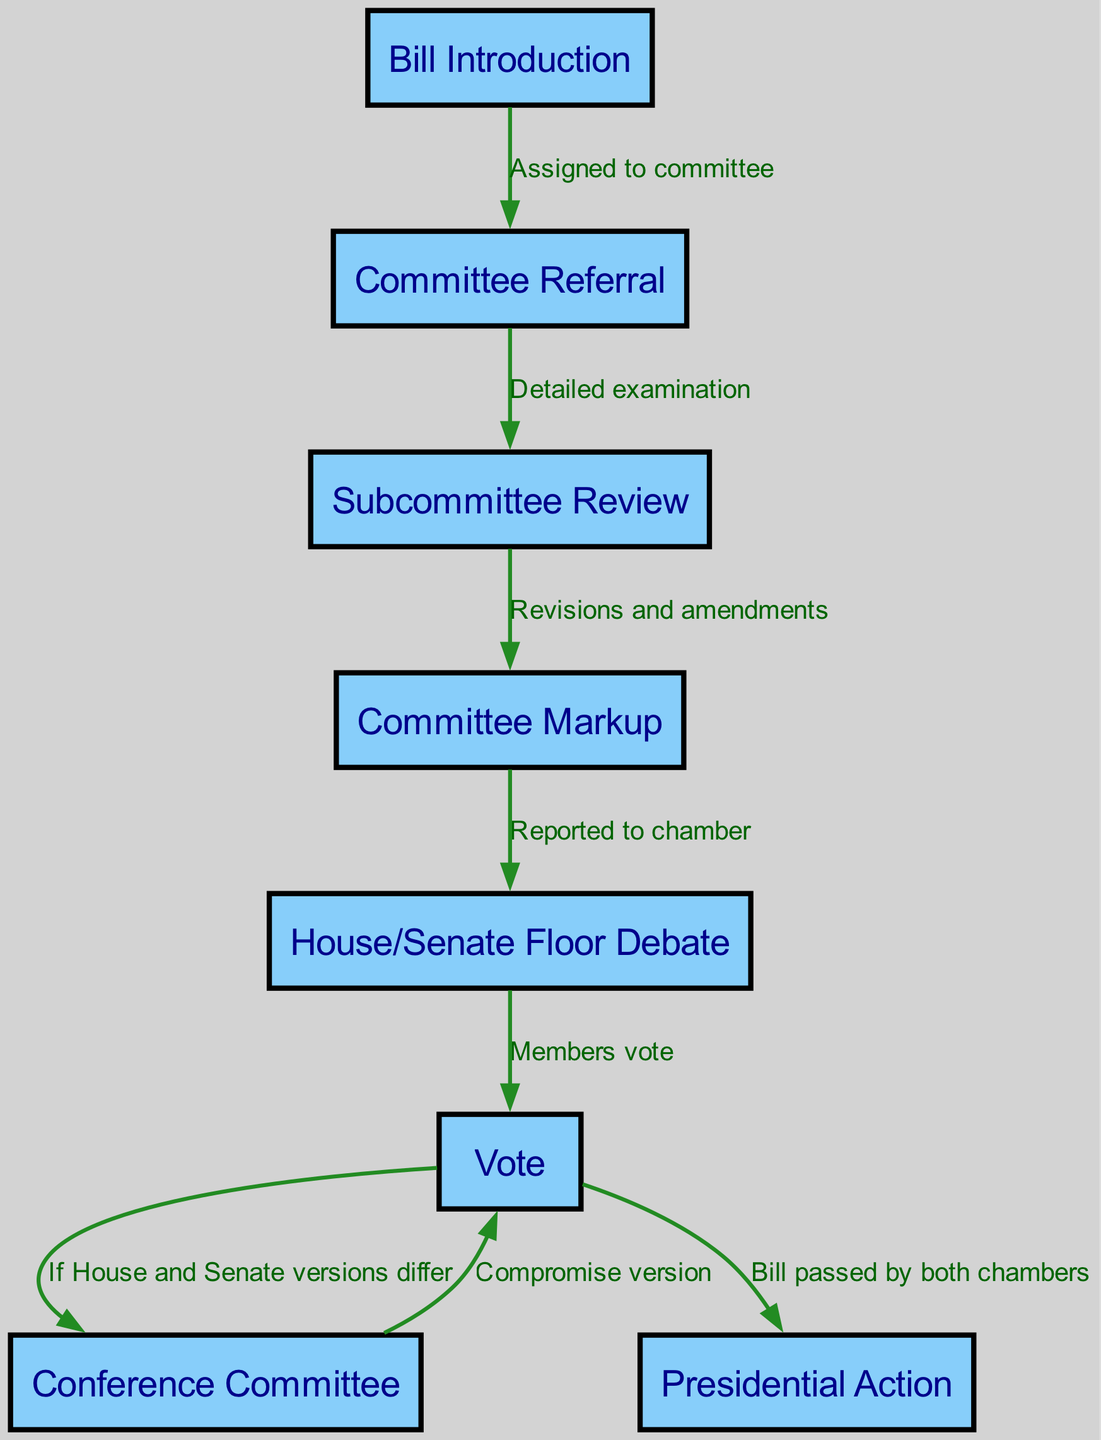What is the first step in the legislative procedure? The diagram shows "Bill Introduction" as the first node. Therefore, the process begins with the introduction of a bill.
Answer: Bill Introduction How many nodes are present in the diagram? By counting the unique steps (nodes) presented in the diagram, there are a total of 8 nodes that represent different stages in the legislative process.
Answer: 8 What is the last step in the process after a vote by both chambers? The final node indicates "Presidential Action," which signifies what happens after the bill has been voted on and passed in both the House and Senate.
Answer: Presidential Action What occurs after the Committee Markup stage? The diagram shows an arrow leading from "Committee Markup" to "House/Senate Floor Debate," indicating that this stage is reported to the chamber for further discussion after markup.
Answer: House/Senate Floor Debate What happens if the House and Senate versions of the bill differ? The diagram outlines a flow that connects to "Conference Committee" if there are differences in the bill versions passed by the House and Senate. Therefore, this step is necessary for resolving those differences.
Answer: Conference Committee What is the relationship between the nodes 'Vote' and 'Conference Committee'? The edge from "Vote" to "Conference Committee" occurs only if the bill versions from the House and Senate differ. It implies that after a vote, if discrepancies exist, a conference committee is called to reconcile the differences.
Answer: If House and Senate versions differ How are the nodes connected representing the detailed examination of a Bill? The "Committee Referral" node leads into "Subcommittee Review," which highlights the connection that once a bill is referred to a committee, it undergoes a detailed examination in a subcommittee.
Answer: Detailed examination What is indicated by the label on the edge between 'Subcommittee Review' and 'Committee Markup'? The label "Revisions and amendments" shows that during this transition from "Subcommittee Review" to "Committee Markup," the bill is revised and potentially amended based on the subcommittee's findings.
Answer: Revisions and amendments 